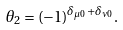Convert formula to latex. <formula><loc_0><loc_0><loc_500><loc_500>\theta _ { 2 } = ( - 1 ) ^ { \delta _ { \mu 0 } + \delta _ { \nu 0 } } .</formula> 